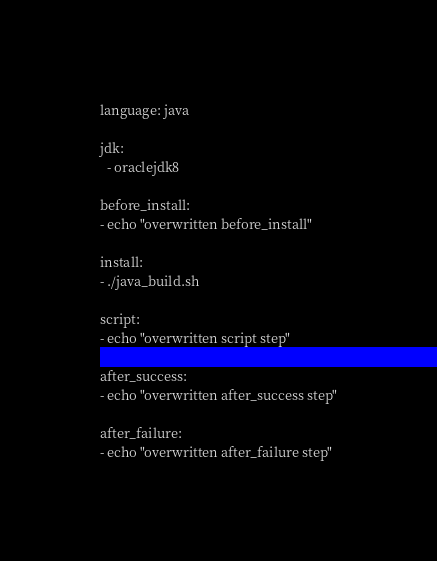<code> <loc_0><loc_0><loc_500><loc_500><_YAML_>language: java

jdk:
  - oraclejdk8

before_install:
- echo "overwritten before_install"

install:
- ./java_build.sh

script:
- echo "overwritten script step"

after_success:
- echo "overwritten after_success step"

after_failure:
- echo "overwritten after_failure step"
</code> 